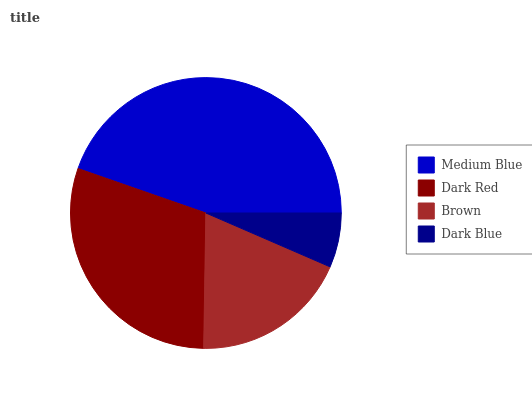Is Dark Blue the minimum?
Answer yes or no. Yes. Is Medium Blue the maximum?
Answer yes or no. Yes. Is Dark Red the minimum?
Answer yes or no. No. Is Dark Red the maximum?
Answer yes or no. No. Is Medium Blue greater than Dark Red?
Answer yes or no. Yes. Is Dark Red less than Medium Blue?
Answer yes or no. Yes. Is Dark Red greater than Medium Blue?
Answer yes or no. No. Is Medium Blue less than Dark Red?
Answer yes or no. No. Is Dark Red the high median?
Answer yes or no. Yes. Is Brown the low median?
Answer yes or no. Yes. Is Medium Blue the high median?
Answer yes or no. No. Is Medium Blue the low median?
Answer yes or no. No. 